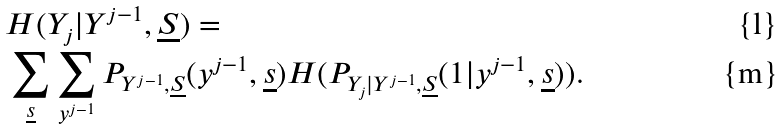Convert formula to latex. <formula><loc_0><loc_0><loc_500><loc_500>& H ( Y _ { j } | Y ^ { j - 1 } , \underline { S } ) = \\ & \sum _ { \underline { s } } \sum _ { y ^ { j - 1 } } P _ { Y ^ { j - 1 } , \underline { S } } ( y ^ { j - 1 } , \underline { s } ) H ( P _ { Y _ { j } | Y ^ { j - 1 } , \underline { S } } ( 1 | y ^ { j - 1 } , \underline { s } ) ) .</formula> 